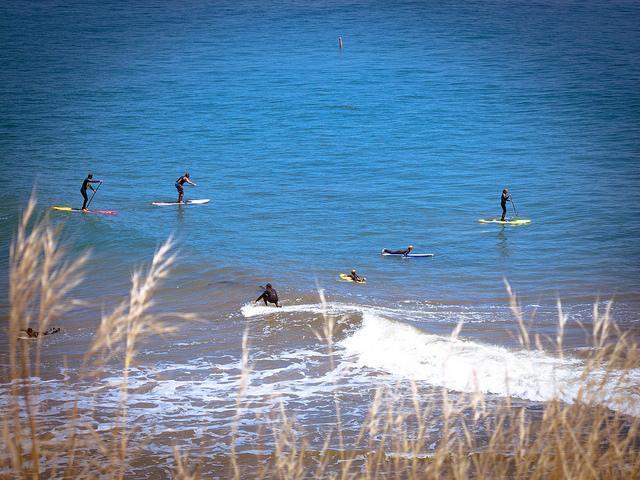How many people are in the ocean?
Give a very brief answer. 7. 